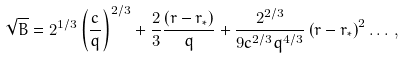Convert formula to latex. <formula><loc_0><loc_0><loc_500><loc_500>\sqrt { B } = 2 ^ { 1 / 3 } \left ( \frac { c } { q } \right ) ^ { 2 / 3 } + \frac { 2 } { 3 } \frac { ( r - r _ { \ast } ) } { q } + \frac { 2 ^ { 2 / 3 } } { 9 c ^ { 2 / 3 } q ^ { 4 / 3 } } \left ( r - r _ { \ast } \right ) ^ { 2 } \dots \, ,</formula> 